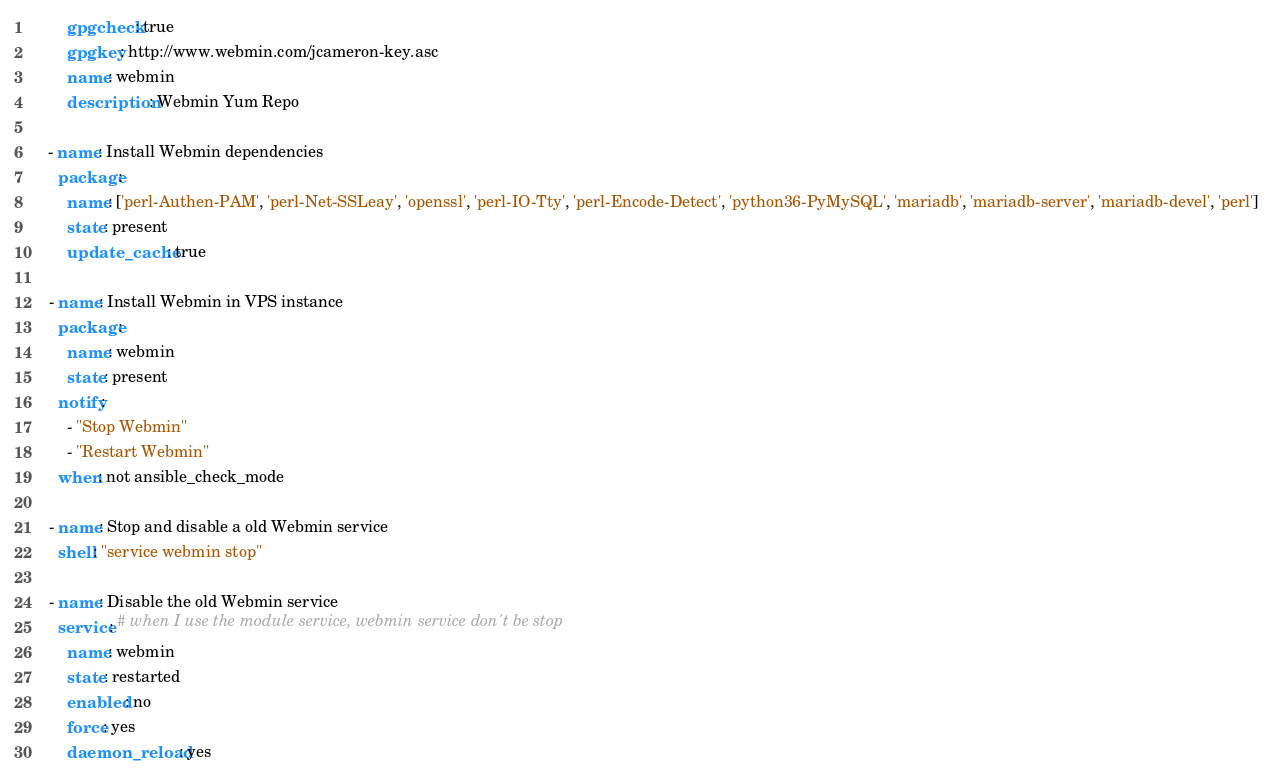Convert code to text. <code><loc_0><loc_0><loc_500><loc_500><_YAML_>        gpgcheck: true
        gpgkey: http://www.webmin.com/jcameron-key.asc
        name: webmin
        description: Webmin Yum Repo

    - name: Install Webmin dependencies
      package:
        name: ['perl-Authen-PAM', 'perl-Net-SSLeay', 'openssl', 'perl-IO-Tty', 'perl-Encode-Detect', 'python36-PyMySQL', 'mariadb', 'mariadb-server', 'mariadb-devel', 'perl']
        state: present
        update_cache: true

    - name: Install Webmin in VPS instance
      package:
        name: webmin
        state: present
      notify: 
        - "Stop Webmin"
        - "Restart Webmin"
      when: not ansible_check_mode

    - name: Stop and disable a old Webmin service
      shell: "service webmin stop"

    - name: Disable the old Webmin service
      service: # when I use the module service, webmin service don't be stop
        name: webmin
        state: restarted
        enabled: no
        force: yes
        daemon_reload: yes</code> 